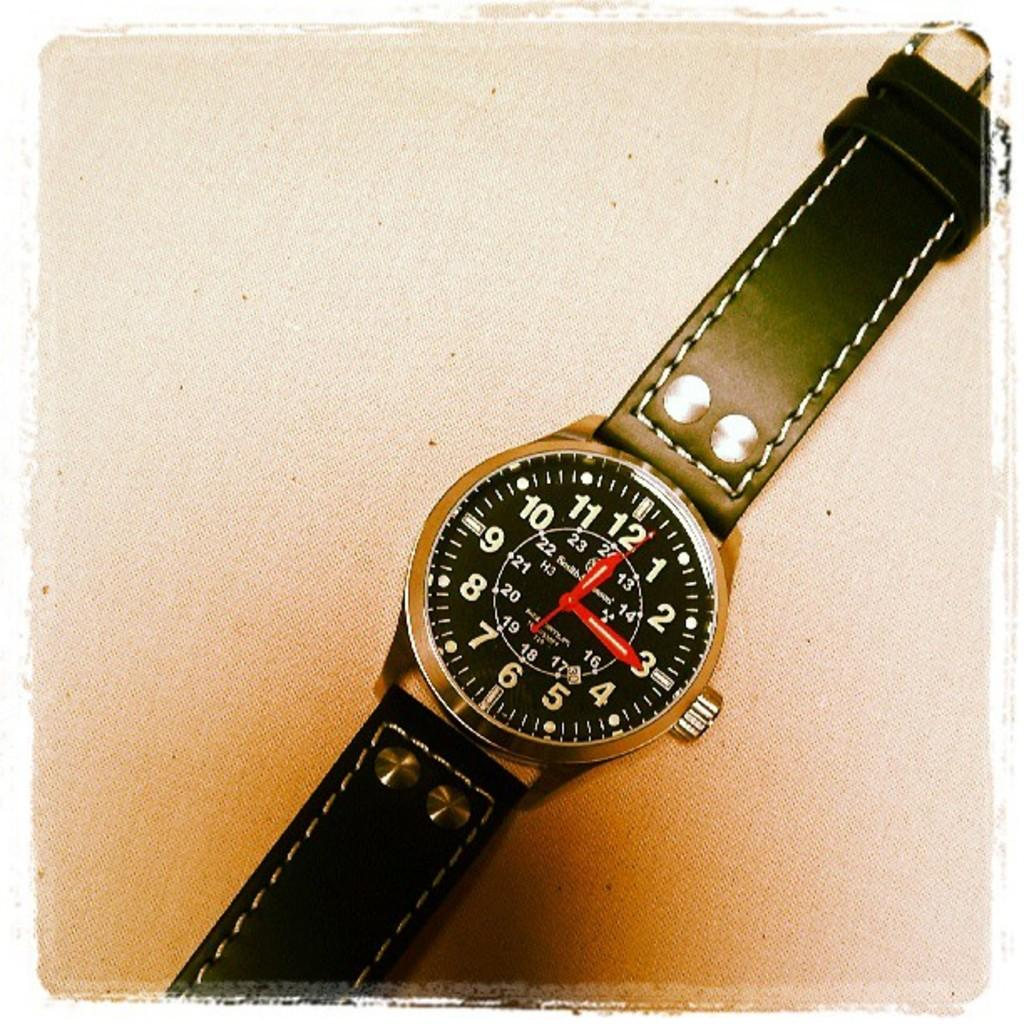Provide a one-sentence caption for the provided image. a watch face with a black band and the time pointing at 12:15. 